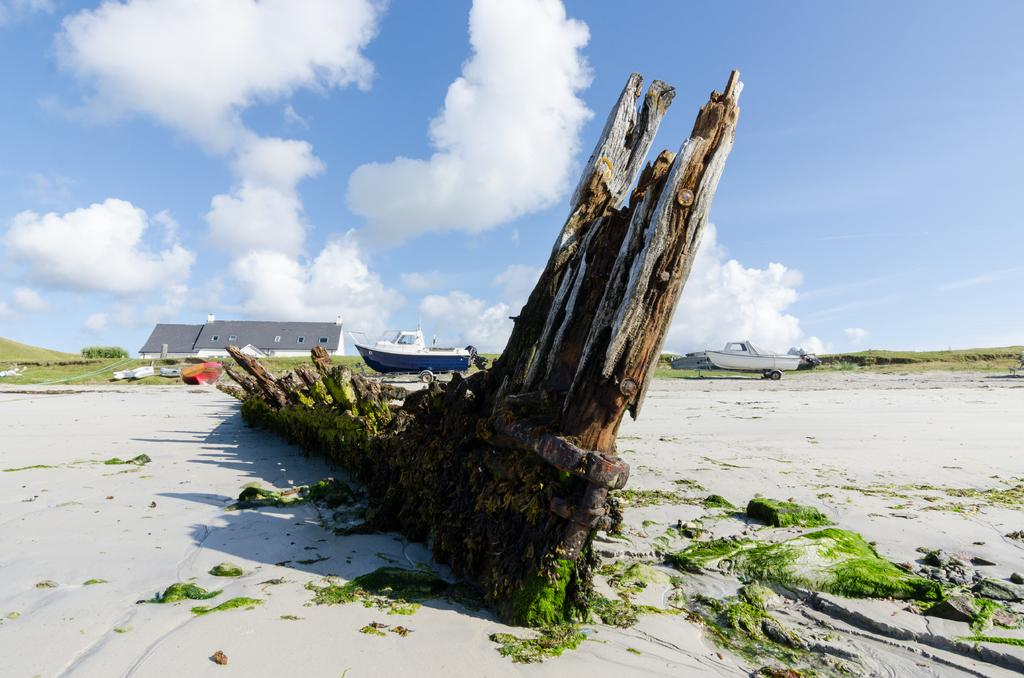What is the main object in the image? There is a tree stem in the image. What else can be seen in the image besides the tree stem? There are boats and buildings visible in the image. What is visible in the background of the image? The sky is visible in the image, and clouds are present in the sky. What type of action is taking place in the image involving a deer? There is no deer present in the image, so no action involving a deer can be observed. 